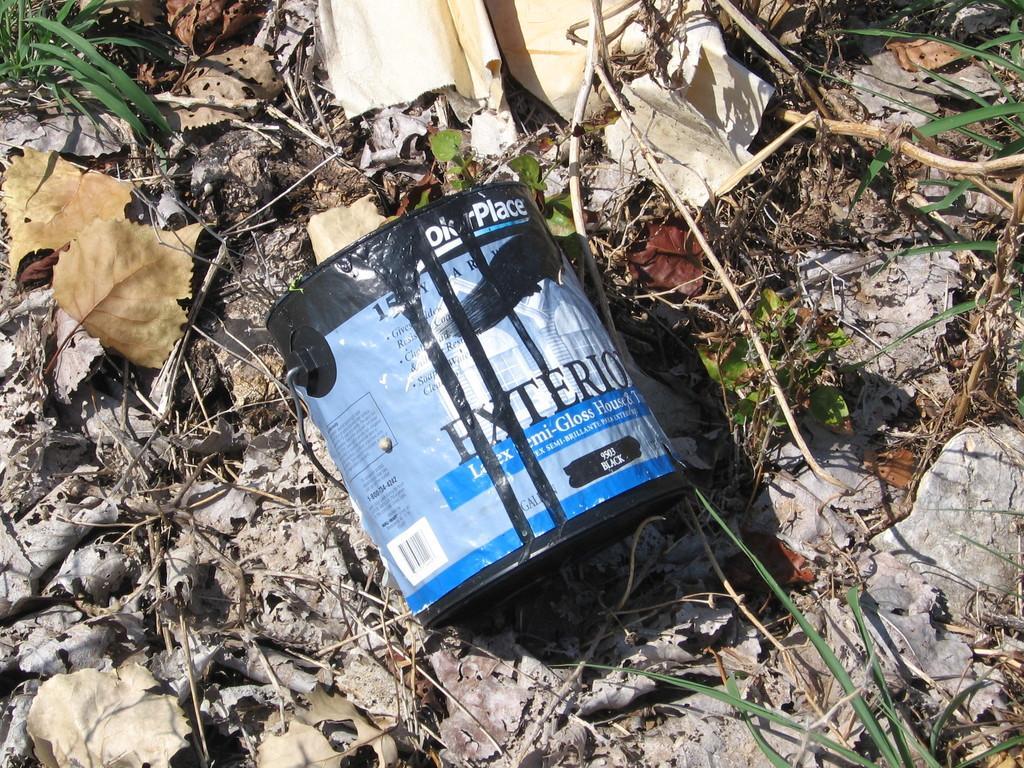Could you give a brief overview of what you see in this image? In this picture we can see a tin, dried leaves, sticks, grass and some objects on the ground. 